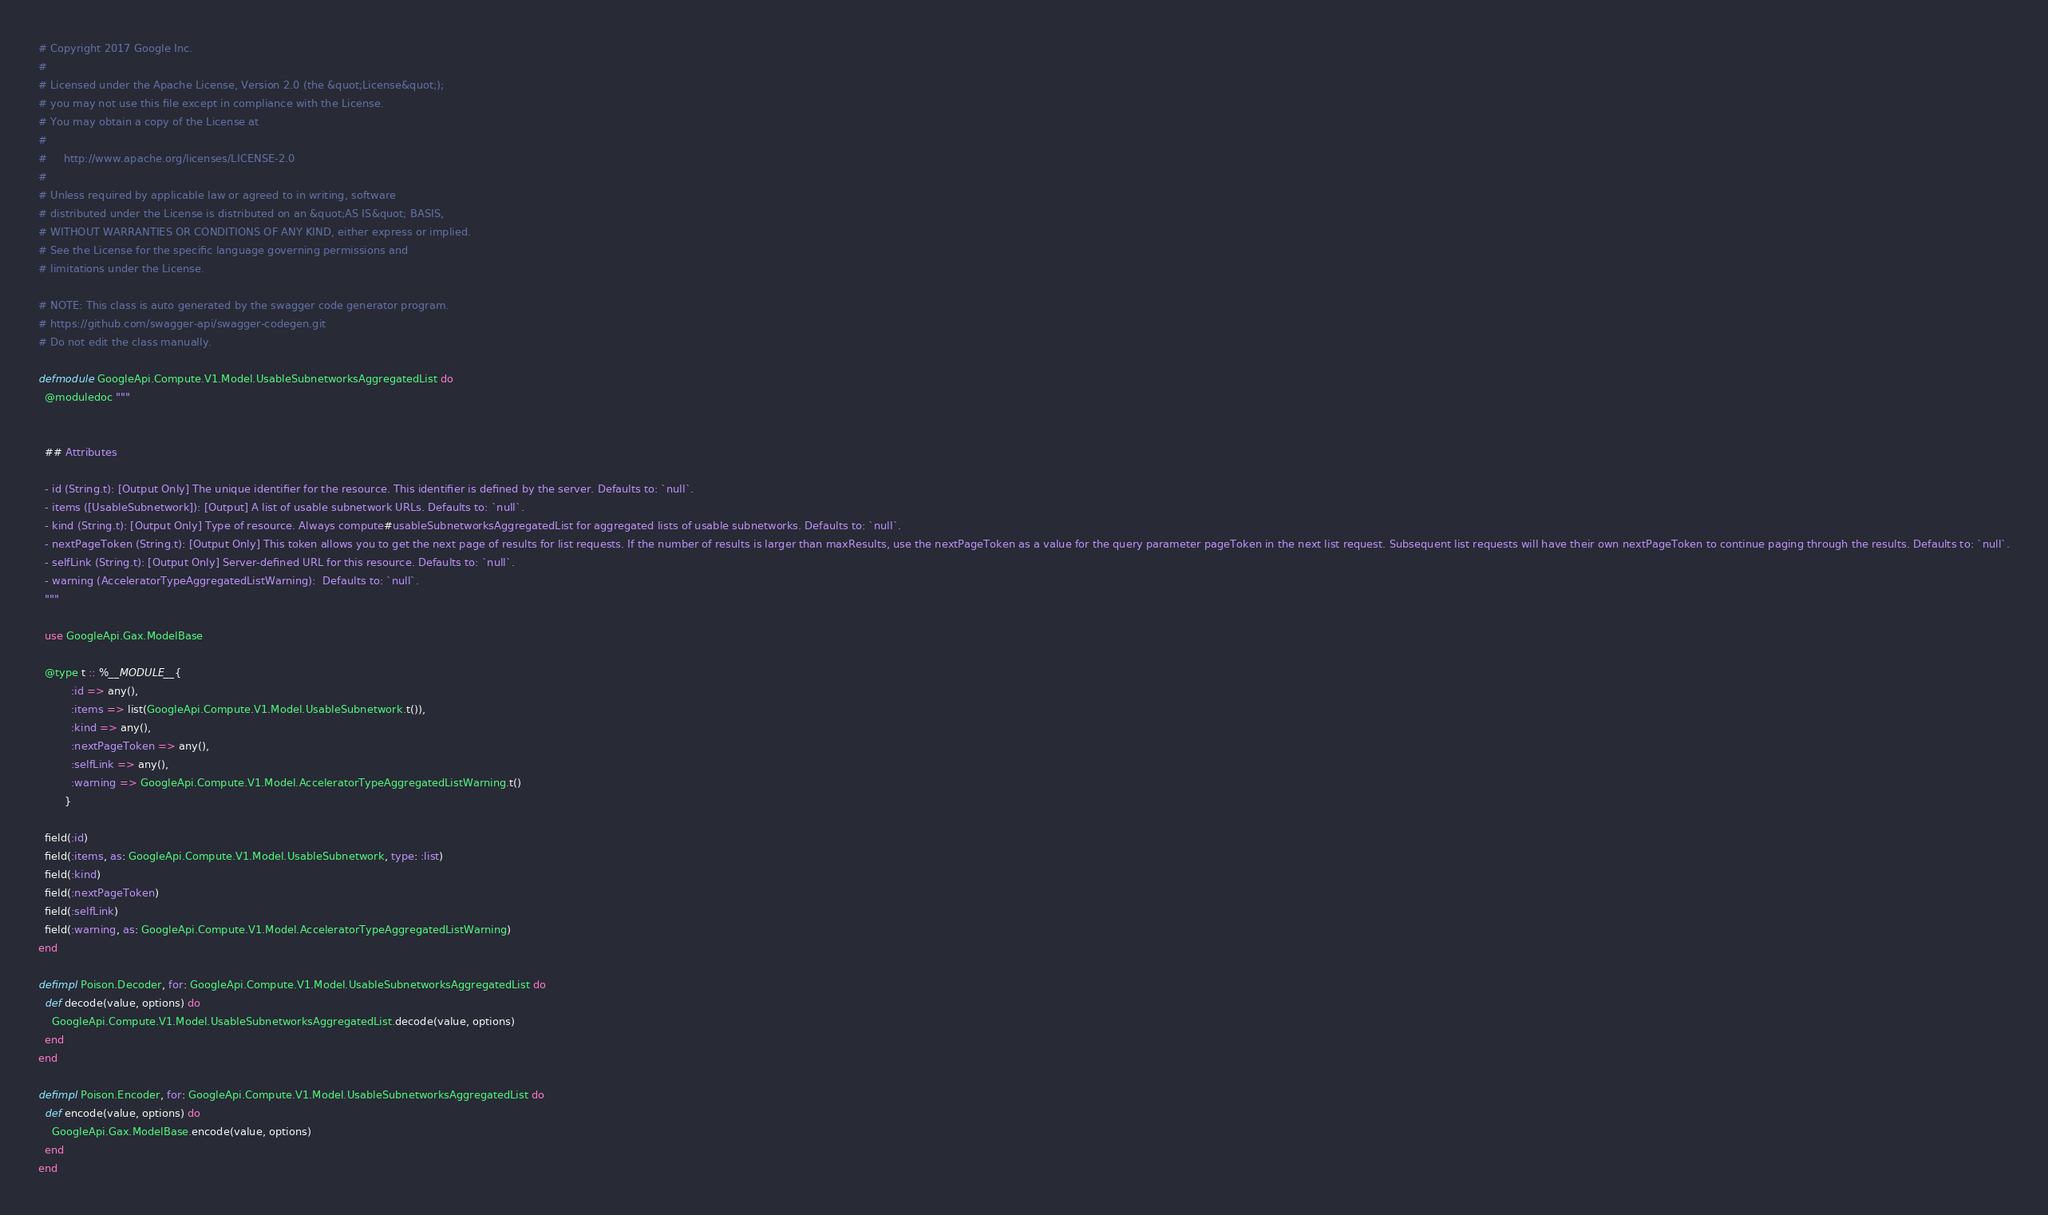Convert code to text. <code><loc_0><loc_0><loc_500><loc_500><_Elixir_># Copyright 2017 Google Inc.
#
# Licensed under the Apache License, Version 2.0 (the &quot;License&quot;);
# you may not use this file except in compliance with the License.
# You may obtain a copy of the License at
#
#     http://www.apache.org/licenses/LICENSE-2.0
#
# Unless required by applicable law or agreed to in writing, software
# distributed under the License is distributed on an &quot;AS IS&quot; BASIS,
# WITHOUT WARRANTIES OR CONDITIONS OF ANY KIND, either express or implied.
# See the License for the specific language governing permissions and
# limitations under the License.

# NOTE: This class is auto generated by the swagger code generator program.
# https://github.com/swagger-api/swagger-codegen.git
# Do not edit the class manually.

defmodule GoogleApi.Compute.V1.Model.UsableSubnetworksAggregatedList do
  @moduledoc """


  ## Attributes

  - id (String.t): [Output Only] The unique identifier for the resource. This identifier is defined by the server. Defaults to: `null`.
  - items ([UsableSubnetwork]): [Output] A list of usable subnetwork URLs. Defaults to: `null`.
  - kind (String.t): [Output Only] Type of resource. Always compute#usableSubnetworksAggregatedList for aggregated lists of usable subnetworks. Defaults to: `null`.
  - nextPageToken (String.t): [Output Only] This token allows you to get the next page of results for list requests. If the number of results is larger than maxResults, use the nextPageToken as a value for the query parameter pageToken in the next list request. Subsequent list requests will have their own nextPageToken to continue paging through the results. Defaults to: `null`.
  - selfLink (String.t): [Output Only] Server-defined URL for this resource. Defaults to: `null`.
  - warning (AcceleratorTypeAggregatedListWarning):  Defaults to: `null`.
  """

  use GoogleApi.Gax.ModelBase

  @type t :: %__MODULE__{
          :id => any(),
          :items => list(GoogleApi.Compute.V1.Model.UsableSubnetwork.t()),
          :kind => any(),
          :nextPageToken => any(),
          :selfLink => any(),
          :warning => GoogleApi.Compute.V1.Model.AcceleratorTypeAggregatedListWarning.t()
        }

  field(:id)
  field(:items, as: GoogleApi.Compute.V1.Model.UsableSubnetwork, type: :list)
  field(:kind)
  field(:nextPageToken)
  field(:selfLink)
  field(:warning, as: GoogleApi.Compute.V1.Model.AcceleratorTypeAggregatedListWarning)
end

defimpl Poison.Decoder, for: GoogleApi.Compute.V1.Model.UsableSubnetworksAggregatedList do
  def decode(value, options) do
    GoogleApi.Compute.V1.Model.UsableSubnetworksAggregatedList.decode(value, options)
  end
end

defimpl Poison.Encoder, for: GoogleApi.Compute.V1.Model.UsableSubnetworksAggregatedList do
  def encode(value, options) do
    GoogleApi.Gax.ModelBase.encode(value, options)
  end
end
</code> 